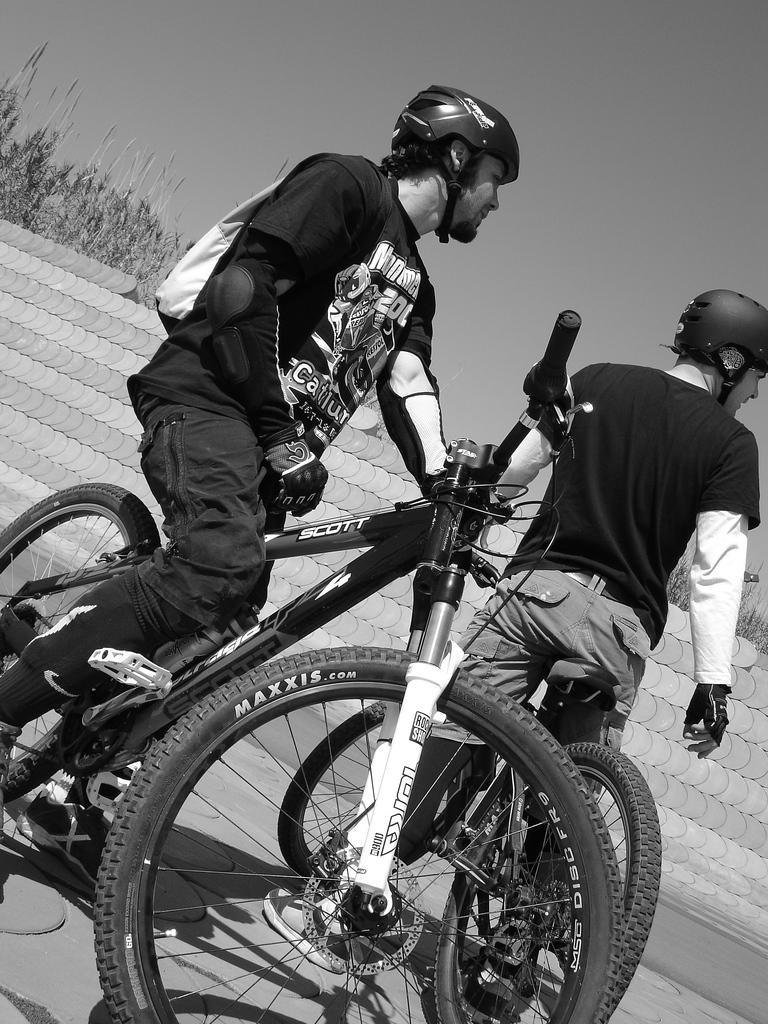Can you describe this image briefly? This is a black and white image. In this I can see two persons are wearing black color t-shirts and riding the bicycles on the road. Behind these persons there is a wall and some trees. On the top of the image I can see the sky. And the two persons are wearing bags and helmets on their heads. 